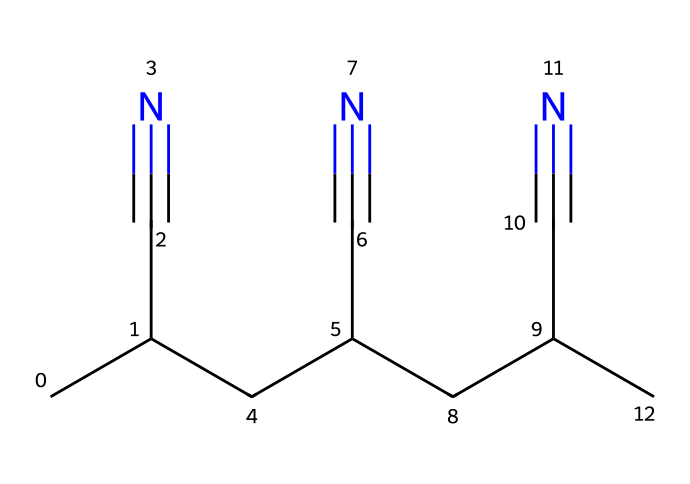how many carbon atoms are in this structure? The structure shows a chain with multiple carbon atoms. By counting the carbon atoms in the provided SMILES representation, there are 9 carbon atoms total.
Answer: 9 how many triple bonds are present in this molecule? The given SMILES representation includes three instances of the group "C#N", indicating three triple bonds between carbon and nitrogen.
Answer: 3 what is the primary functional group in this chemical? The SMILES notation includes the presence of "C#N", which corresponds to the cyano group (-C≡N). This is the primary functional group in the structure.
Answer: cyano group what is the total number of nitrogen atoms in this structure? The present SMILES representation shows three instances of "C#N", indicating there is one nitrogen atom for each cyano group. Thus, there are 3 nitrogen atoms in total.
Answer: 3 what type of fiber is represented by this chemical structure? Given the characteristics of the structure, it represents acrylic fibers, which are known for their use in carpets and textiles due to the presence of cyano groups.
Answer: acrylic fibers does this chemical likely have a strong or weak odor? Commonly, chemicals that contain the cyano group can exhibit a strong odor; hence, this chemical likely has a strong odor due to the presence of multiple cyano groups.
Answer: strong odor 